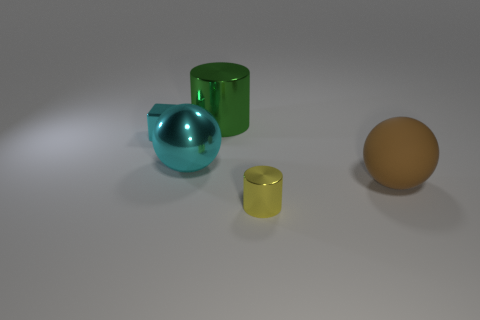Does the tiny block have the same material as the small yellow cylinder?
Your response must be concise. Yes. How many big things are either matte cubes or yellow shiny things?
Offer a terse response. 0. Is there any other thing that has the same shape as the green shiny thing?
Your answer should be compact. Yes. Is there anything else that has the same size as the yellow thing?
Ensure brevity in your answer.  Yes. The large cylinder that is the same material as the small cube is what color?
Your answer should be very brief. Green. The small metal thing left of the large cyan metallic thing is what color?
Provide a succinct answer. Cyan. What number of metal cubes are the same color as the big cylinder?
Your answer should be very brief. 0. Are there fewer cyan objects right of the big cyan shiny thing than big brown objects in front of the small yellow metal object?
Provide a short and direct response. No. What number of objects are on the left side of the rubber sphere?
Make the answer very short. 4. Is there another cyan cube made of the same material as the cyan block?
Your answer should be compact. No. 